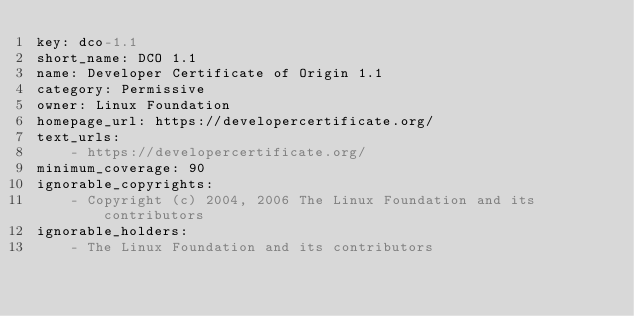Convert code to text. <code><loc_0><loc_0><loc_500><loc_500><_YAML_>key: dco-1.1
short_name: DCO 1.1
name: Developer Certificate of Origin 1.1
category: Permissive
owner: Linux Foundation
homepage_url: https://developercertificate.org/
text_urls:
    - https://developercertificate.org/
minimum_coverage: 90
ignorable_copyrights:
    - Copyright (c) 2004, 2006 The Linux Foundation and its contributors
ignorable_holders:
    - The Linux Foundation and its contributors
</code> 